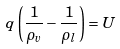Convert formula to latex. <formula><loc_0><loc_0><loc_500><loc_500>q \left ( \frac { 1 } { \rho _ { v } } - \frac { 1 } { \rho _ { l } } \right ) = U</formula> 